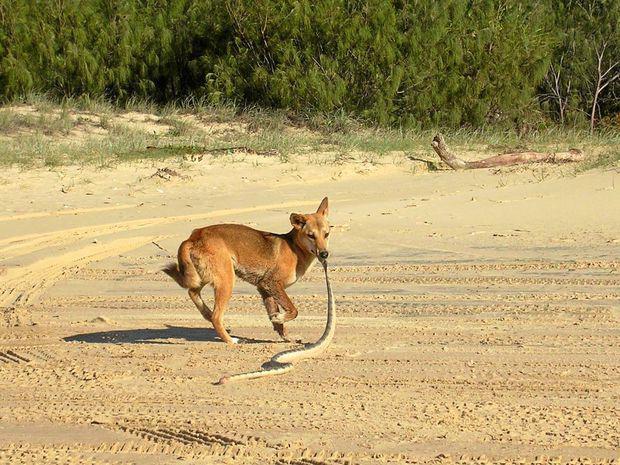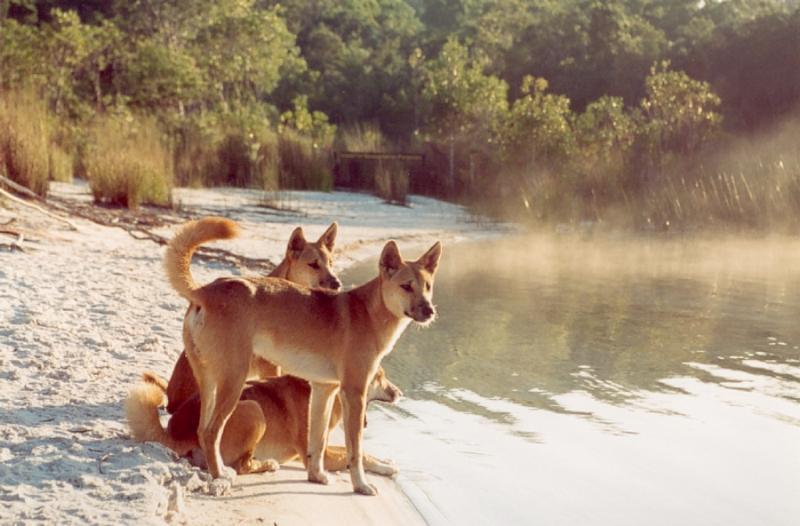The first image is the image on the left, the second image is the image on the right. For the images shown, is this caption "One of the photos shows a wild dog biting another animal." true? Answer yes or no. Yes. The first image is the image on the left, the second image is the image on the right. For the images shown, is this caption "An image shows a wild dog grasping part of another animal with its mouth." true? Answer yes or no. Yes. 